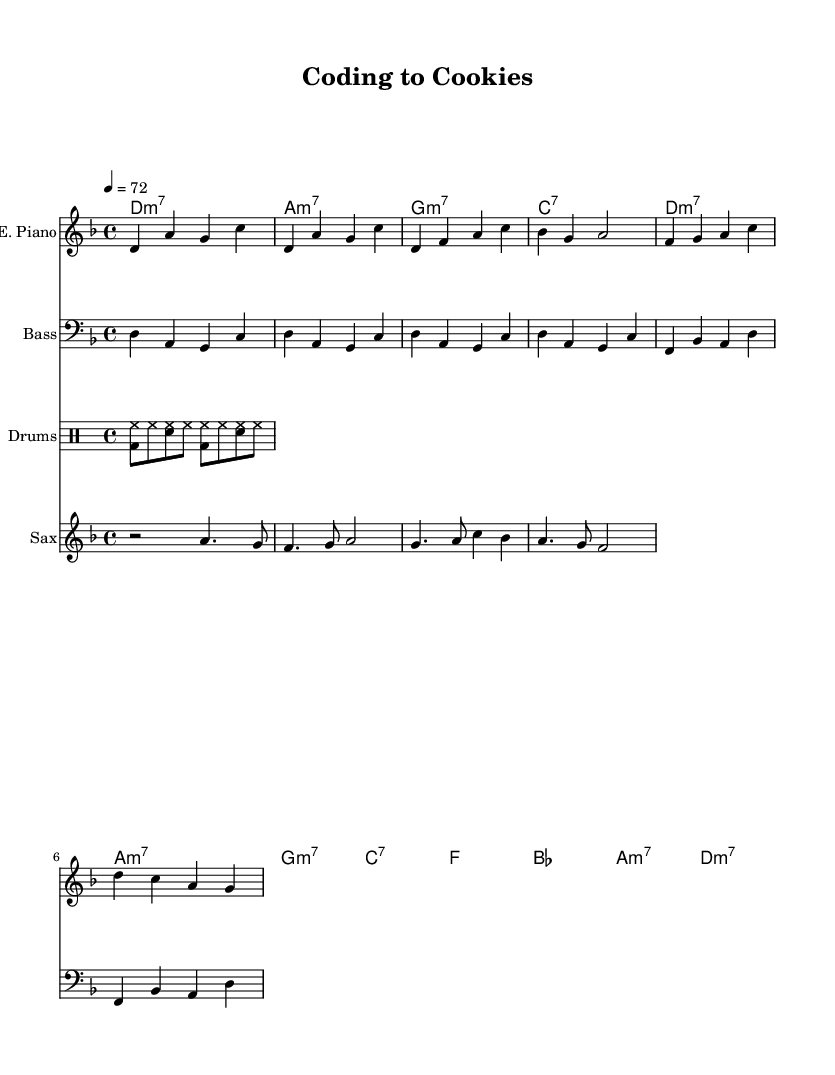What is the key signature of this music? The key signature indicated before the staff shows one flat, which corresponds to the key of D minor.
Answer: D minor What is the time signature of this music? The time signature is indicated at the beginning of the score and shows a '4' over a '4', meaning it has four beats per measure.
Answer: 4/4 What is the tempo marking for this piece? The tempo marking is shown at the beginning of the score with the indication '4 = 72', which indicates how many beats per minute are played.
Answer: 72 How many measures are in the tone's verse section? The verse section consists of two measures as determined by counting the measures from the electric piano part in the verse.
Answer: 2 What instruments are used in this arrangement? The score displays the names of each instrument used, which shows Electric Piano, Bass, Drums, and Saxophone.
Answer: Electric Piano, Bass, Drums, Saxophone What is the chord progression in the chorus? By looking at the chord names during the chorus section, the progression is F, B-flat, A minor, and D minor.
Answer: F, B-flat, A minor, D minor What type of groove is indicated for the drums part? The drum part contains two instruments, showing a hip-hop groove using brushes as indicated in the drumming mode section of the score.
Answer: Hip-hop groove 